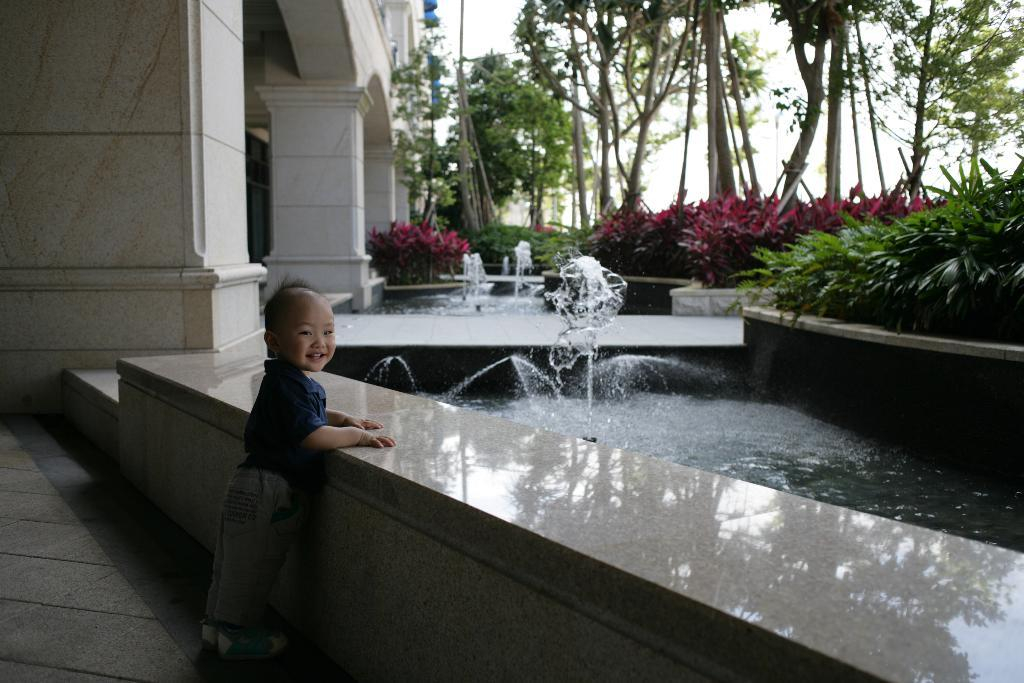What is the main subject of the image? The main subject of the image is a child. Where is the child located in the image? The child is standing near a wall. What is the child's expression in the image? The child is smiling. What can be seen in the background of the image? There is a water fountain, plants, pillars, trees, and the sky visible in the background of the image. What type of vacation is the child planning based on the image? There is no indication in the image that the child is planning a vacation, so it cannot be determined from the picture. 